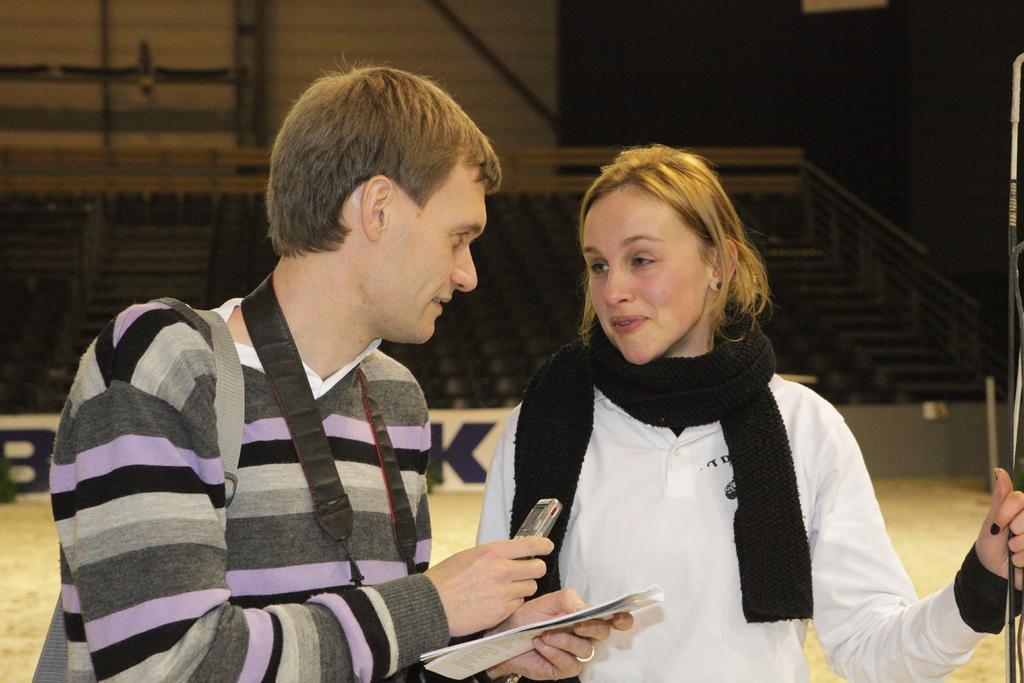Could you give a brief overview of what you see in this image? In this image in the foreground there is one man and one woman and the man is holding some papers and a mobile phone, in the background there are some stairs, railing and a wall. 